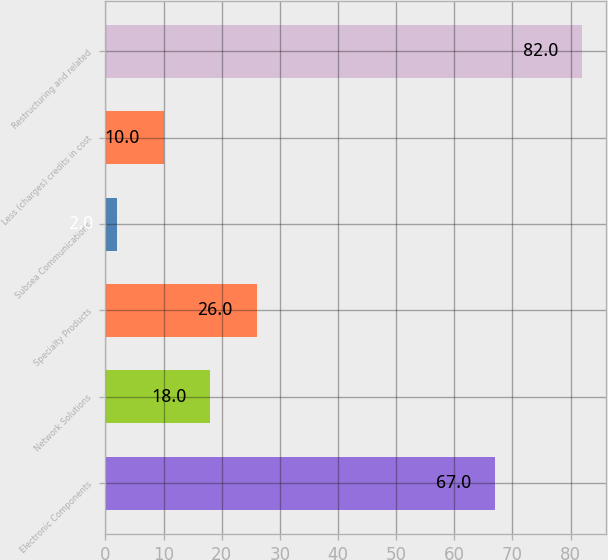<chart> <loc_0><loc_0><loc_500><loc_500><bar_chart><fcel>Electronic Components<fcel>Network Solutions<fcel>Specialty Products<fcel>Subsea Communications<fcel>Less (charges) credits in cost<fcel>Restructuring and related<nl><fcel>67<fcel>18<fcel>26<fcel>2<fcel>10<fcel>82<nl></chart> 